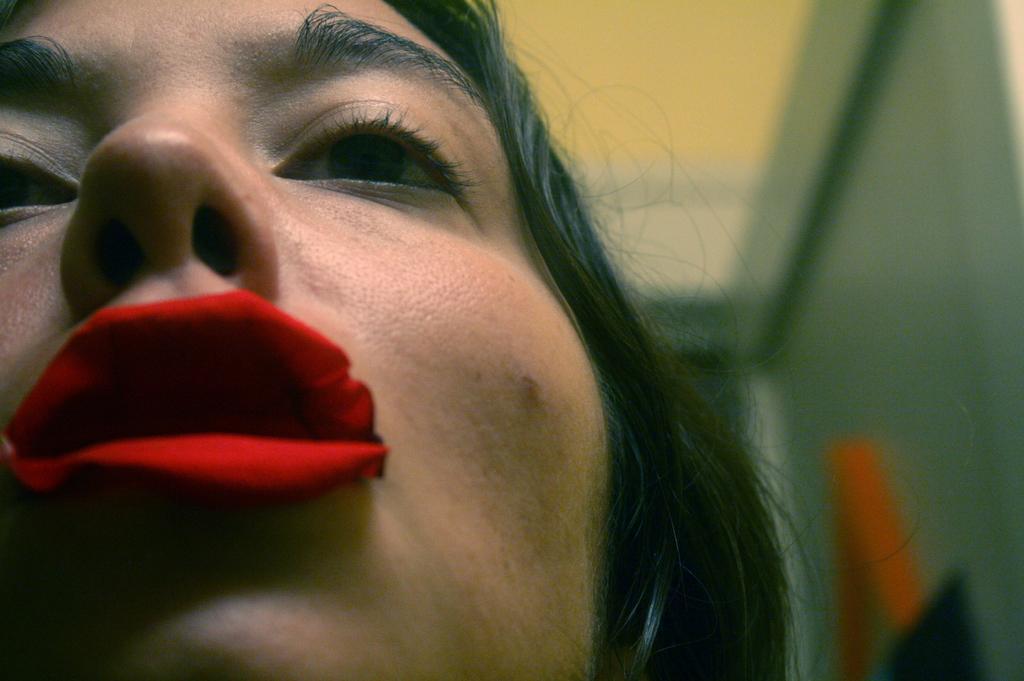How would you summarize this image in a sentence or two? In the foreground of this image, on the left, there is a woman and there is a rose petal on her lips and the background image is blur. 